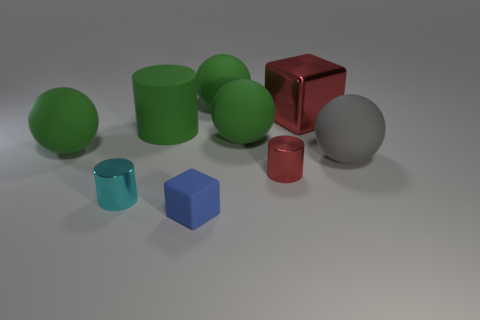Subtract all cyan blocks. How many green spheres are left? 3 Subtract 1 balls. How many balls are left? 3 Subtract all gray balls. How many balls are left? 3 Subtract all red balls. Subtract all purple cylinders. How many balls are left? 4 Add 1 big balls. How many objects exist? 10 Subtract all spheres. How many objects are left? 5 Add 6 small cyan metallic cylinders. How many small cyan metallic cylinders are left? 7 Add 3 gray metallic things. How many gray metallic things exist? 3 Subtract 0 purple cylinders. How many objects are left? 9 Subtract all cyan cylinders. Subtract all spheres. How many objects are left? 4 